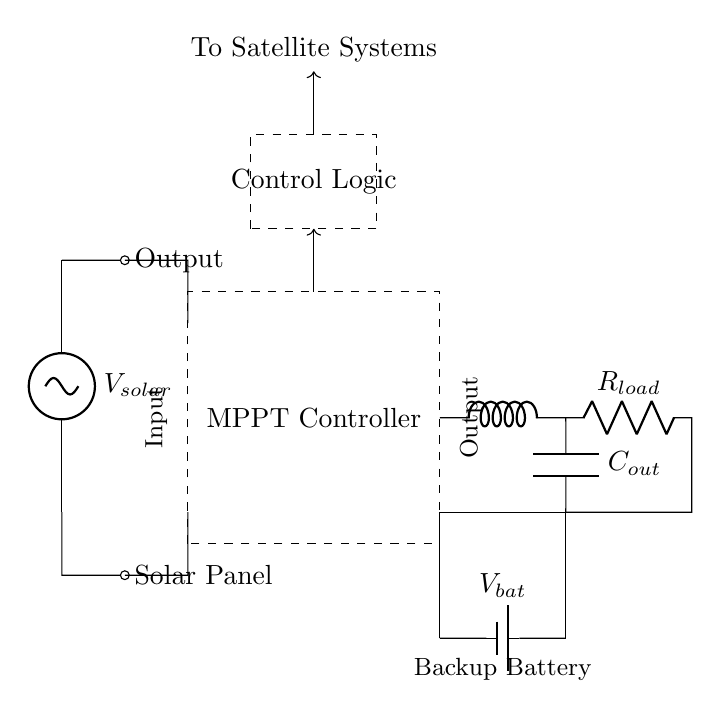What component is used to control the maximum power from the solar panel? The component is the MPPT Controller, which regulates the output power from the solar panel to optimize energy utilization.
Answer: MPPT Controller What is the role of the DC-DC Converter in this circuit? The DC-DC Converter adjusts the voltage and current levels to match the requirements of the load while ensuring efficient energy transfer from the solar panel.
Answer: Adjust voltage What is the battery voltage denoted in the circuit? The battery voltage is marked as V_bat, denoting the energy stored for backup power in the circuit.
Answer: V_bat How many main components are visibly listed in the circuit? The circuit diagram displays four main components: Solar Panel, MPPT Controller, DC-DC Converter, and Load with Backup Battery.
Answer: Four What happens to the energy from the solar panel if the load is disconnected? If the load is disconnected, the energy can be redirected to charge the battery instead, maintaining system efficiency.
Answer: Redirected to battery What type of load is represented in the circuit? The load is represented as a resistor, indicating it draws current from the circuit for its operation.
Answer: Resistor 